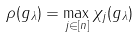Convert formula to latex. <formula><loc_0><loc_0><loc_500><loc_500>\rho ( g _ { \lambda } ) = \max _ { j \in [ n ] } \chi _ { j } ( g _ { \lambda } )</formula> 